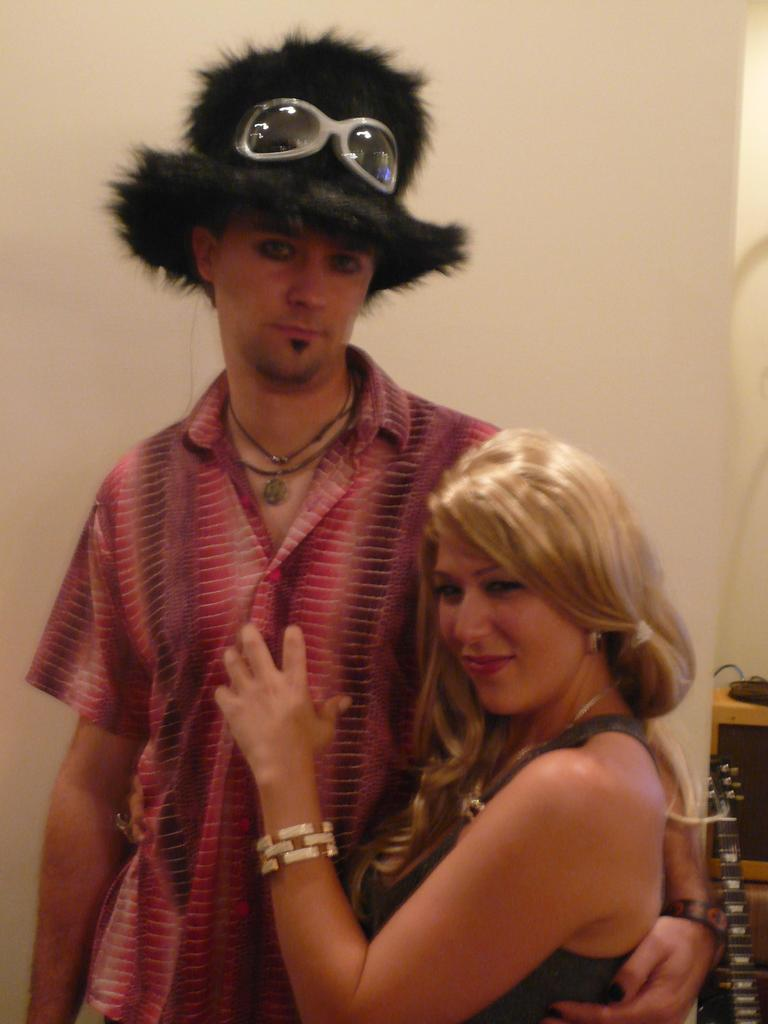What is the man wearing on his head in the image? The man is wearing a hat in the image. Who is standing beside the man? There is a woman beside the man in the image. What can be seen behind the man and woman? There is a wall visible behind the man and woman. What is located on the right side of the image? There are objects on the right side of the image. How many quarters can be seen on the man's leg in the image? There are no quarters visible on the man's leg in the image. What type of car is parked behind the wall in the image? There is no car visible behind the wall in the image. 